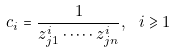<formula> <loc_0><loc_0><loc_500><loc_500>c _ { i } = \frac { 1 } { z _ { j 1 } ^ { i } \cdot \dots \cdot z _ { j n } ^ { i } } , \ i \geqslant 1</formula> 